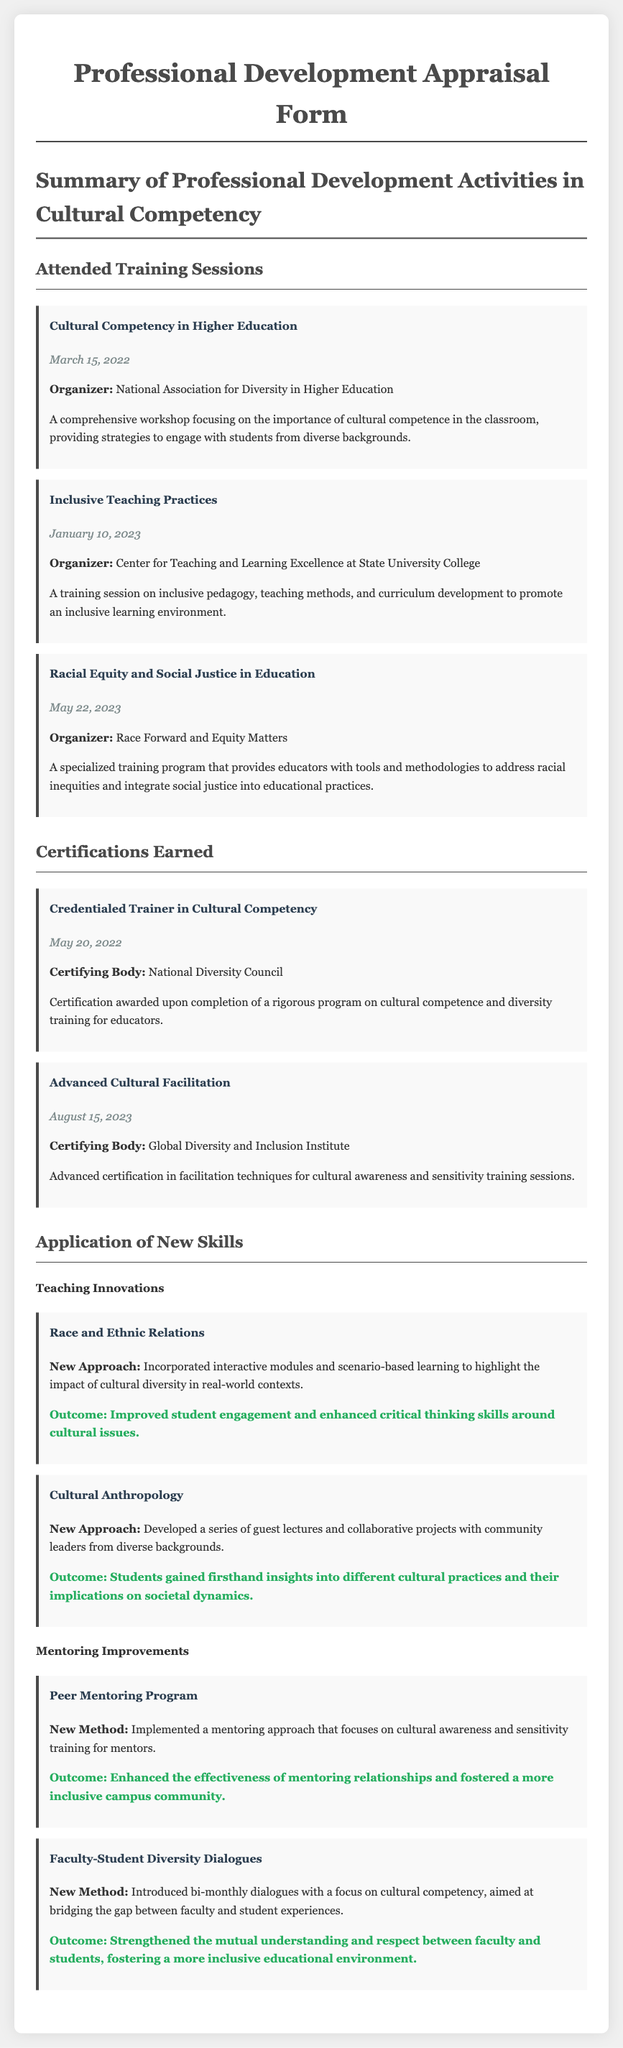What is the title of the first training session attended? The title of the first training session provides a specific topic covered, which is listed in the "Attended Training Sessions" section.
Answer: Cultural Competency in Higher Education What date was the certification for "Credentialed Trainer in Cultural Competency" earned? The date for each certification is provided and can be directly retrieved from the "Certifications Earned" section.
Answer: May 20, 2022 Who organized the "Racial Equity and Social Justice in Education" training? The organizer's name for each training session is explicitly mentioned, which helps identify the training source.
Answer: Race Forward and Equity Matters What new approach was introduced in the course "Race and Ethnic Relations"? This detail highlights how new skills were applied in teaching, emphasizing innovation and adaptation based on training.
Answer: Incorporated interactive modules and scenario-based learning What was the outcome of the "Faculty-Student Diversity Dialogues"? The outcome reflects the effectiveness and impact of the new method implemented, summarizing the result of the initiative.
Answer: Strengthened the mutual understanding and respect How many training sessions are listed in the document? The count of training sessions provides a quantitative measure of professional development activities mentioned in the document.
Answer: Three What is one of the focuses in the "Peer Mentoring Program"? This question connects to the application of new skills in mentoring and highlights the specific emphasis of the program.
Answer: Cultural awareness and sensitivity training Which certifying body awarded the "Advanced Cultural Facilitation"? The certifying body's name adds credibility and context to the certification earned, which is listed in the "Certifications Earned" section.
Answer: Global Diversity and Inclusion Institute 